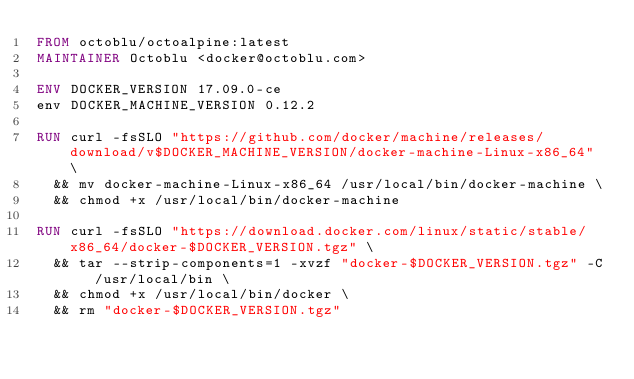Convert code to text. <code><loc_0><loc_0><loc_500><loc_500><_Dockerfile_>FROM octoblu/octoalpine:latest
MAINTAINER Octoblu <docker@octoblu.com>

ENV DOCKER_VERSION 17.09.0-ce
env DOCKER_MACHINE_VERSION 0.12.2

RUN curl -fsSLO "https://github.com/docker/machine/releases/download/v$DOCKER_MACHINE_VERSION/docker-machine-Linux-x86_64" \
  && mv docker-machine-Linux-x86_64 /usr/local/bin/docker-machine \
  && chmod +x /usr/local/bin/docker-machine

RUN curl -fsSLO "https://download.docker.com/linux/static/stable/x86_64/docker-$DOCKER_VERSION.tgz" \
  && tar --strip-components=1 -xvzf "docker-$DOCKER_VERSION.tgz" -C /usr/local/bin \
  && chmod +x /usr/local/bin/docker \
  && rm "docker-$DOCKER_VERSION.tgz"
</code> 